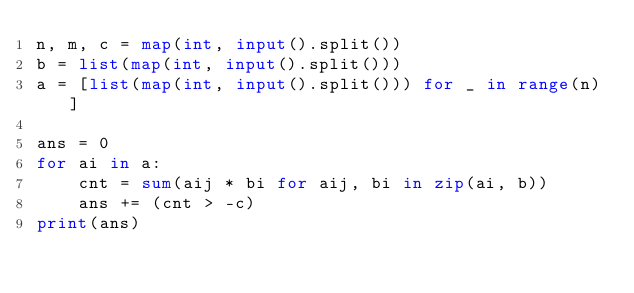Convert code to text. <code><loc_0><loc_0><loc_500><loc_500><_Python_>n, m, c = map(int, input().split())
b = list(map(int, input().split()))
a = [list(map(int, input().split())) for _ in range(n)]

ans = 0
for ai in a:
    cnt = sum(aij * bi for aij, bi in zip(ai, b))
    ans += (cnt > -c)
print(ans)
</code> 